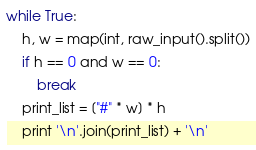<code> <loc_0><loc_0><loc_500><loc_500><_Python_>while True:
    h, w = map(int, raw_input().split())
    if h == 0 and w == 0:
        break
    print_list = ["#" * w] * h
    print '\n'.join(print_list) + '\n'</code> 